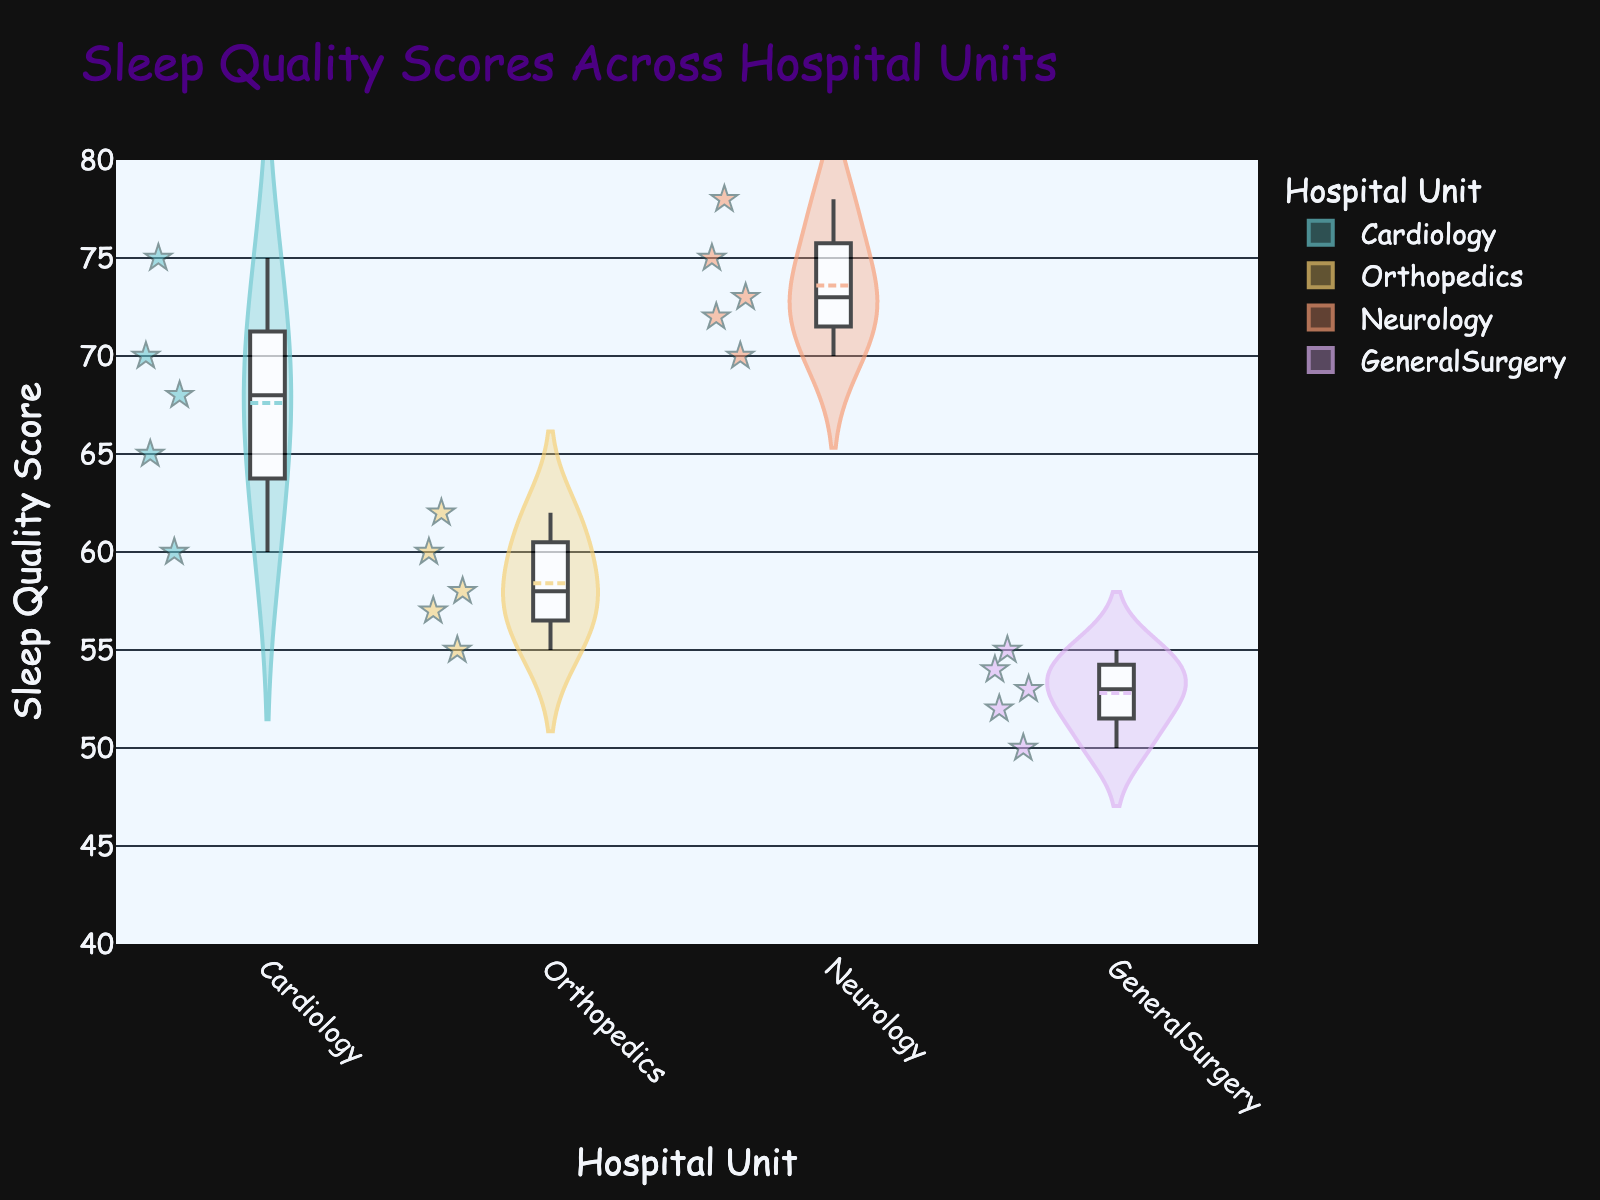What is the title of the figure? The title of the figure is usually found at the top and provides a summary of what the plot represents. In this case, it reads "Sleep Quality Scores Across Hospital Units".
Answer: Sleep Quality Scores Across Hospital Units Which hospital unit has the highest median sleep quality score? To determine this, look at the central line inside each violin plot which represents the median. The Neurology unit's violin plot has the highest median line compared to the other units.
Answer: Neurology What is the range of sleep quality scores observed for the General Surgery unit? The range can be determined by observing the highest and lowest points within the General Surgery unit's violin plot. The scores range from 50 to 55.
Answer: 50 to 55 How do the sleep quality scores vary for patients in the Cardiology unit? The variance in sleep quality scores is shown by the spread width of the violin plot for the Cardiology unit. Patients in the Cardiology unit have scores ranging roughly from 60 to 75, with a median around 68.
Answer: 60 to 75 Which unit shows the widest spread in sleep quality scores? By comparing the width of all the violin plots, the Cardiology unit shows the widest spread from around 60 to 75, indicating the most variability in scores.
Answer: Cardiology Is there a noticeable difference in sleep quality scores between Orthopedics and General Surgery units? Comparing the violin plots of Orthopedics and General Surgery, the Orthopedics unit has scores ranging from 55 to 62, whereas General Surgery's scores range from 50 to 55. The Orthopedics unit generally has higher sleep quality scores.
Answer: Yes Which unit's patients tend to have the lowest sleep quality scores? This can be identified by observing the lowest points of each violin plot. General Surgery has the lowest sleep quality scores ranging from 50 to 55.
Answer: General Surgery What colors are used for representing different units? The different colors help distinguish each unit quickly. Cardiology, Orthopedics, Neurology, and General Surgery are represented using distinct pastel colors.
Answer: Pastel colors Among the hospital units, which one has the sleep quality scores closest to the top end of the y-axis range? Looking at the y-axis range (40 to 80), the Neurology unit's scores are closest to the top end, with scores from about 70 to 78.
Answer: Neurology What are the unique markers used to indicate individual data points on the plot? The unique markers, identified as stars with a dark slate grey outline, are used to indicate individual data points.
Answer: Stars 